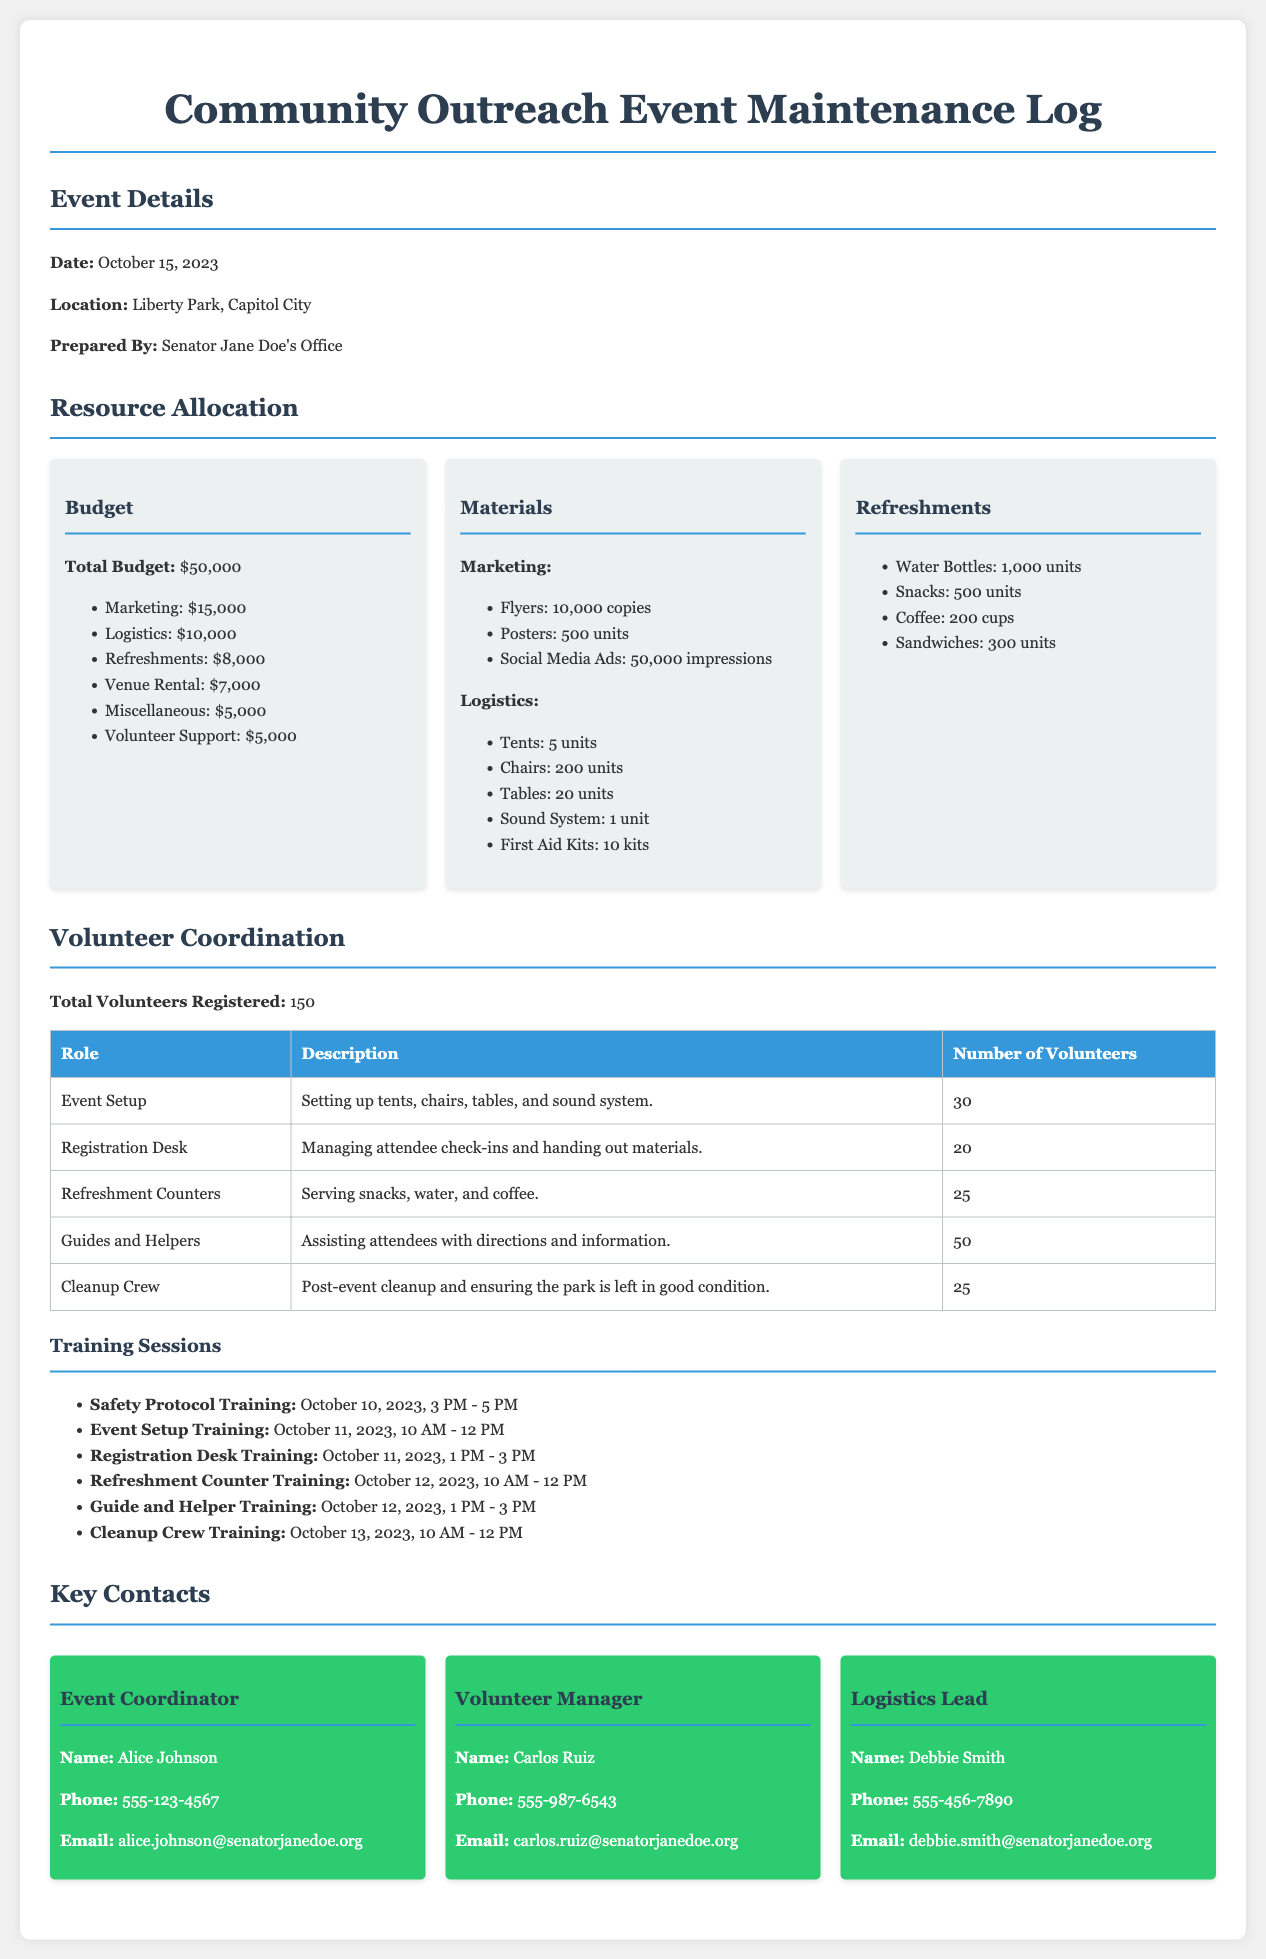what is the date of the event? The date of the event is stated in the Event Details section of the document.
Answer: October 15, 2023 what is the total budget allocated for the event? The total budget is listed under Resource Allocation in the document.
Answer: $50,000 how many volunteers are registered for the event? The total number of volunteers registered is mentioned in the Volunteer Coordination section.
Answer: 150 who is the Event Coordinator? The name of the Event Coordinator is provided in the Key Contacts section of the document.
Answer: Alice Johnson what role has the highest number of volunteers? This can be determined by looking at the number of volunteers listed for each role in the Volunteer Coordination table.
Answer: Guides and Helpers how many units of water bottles are allocated for refreshments? The number of water bottles is specified under the Refreshments section.
Answer: 1,000 units what is the budget allocated for marketing? The budget for marketing is itemized under Resource Allocation.
Answer: $15,000 which training session occurs last before the event? The training sessions are listed chronologically, and the last one can be identified by looking at the dates.
Answer: Cleanup Crew Training how many first aid kits are prepared for the event? The number of first aid kits is noted in the Materials section under Logistics.
Answer: 10 kits 